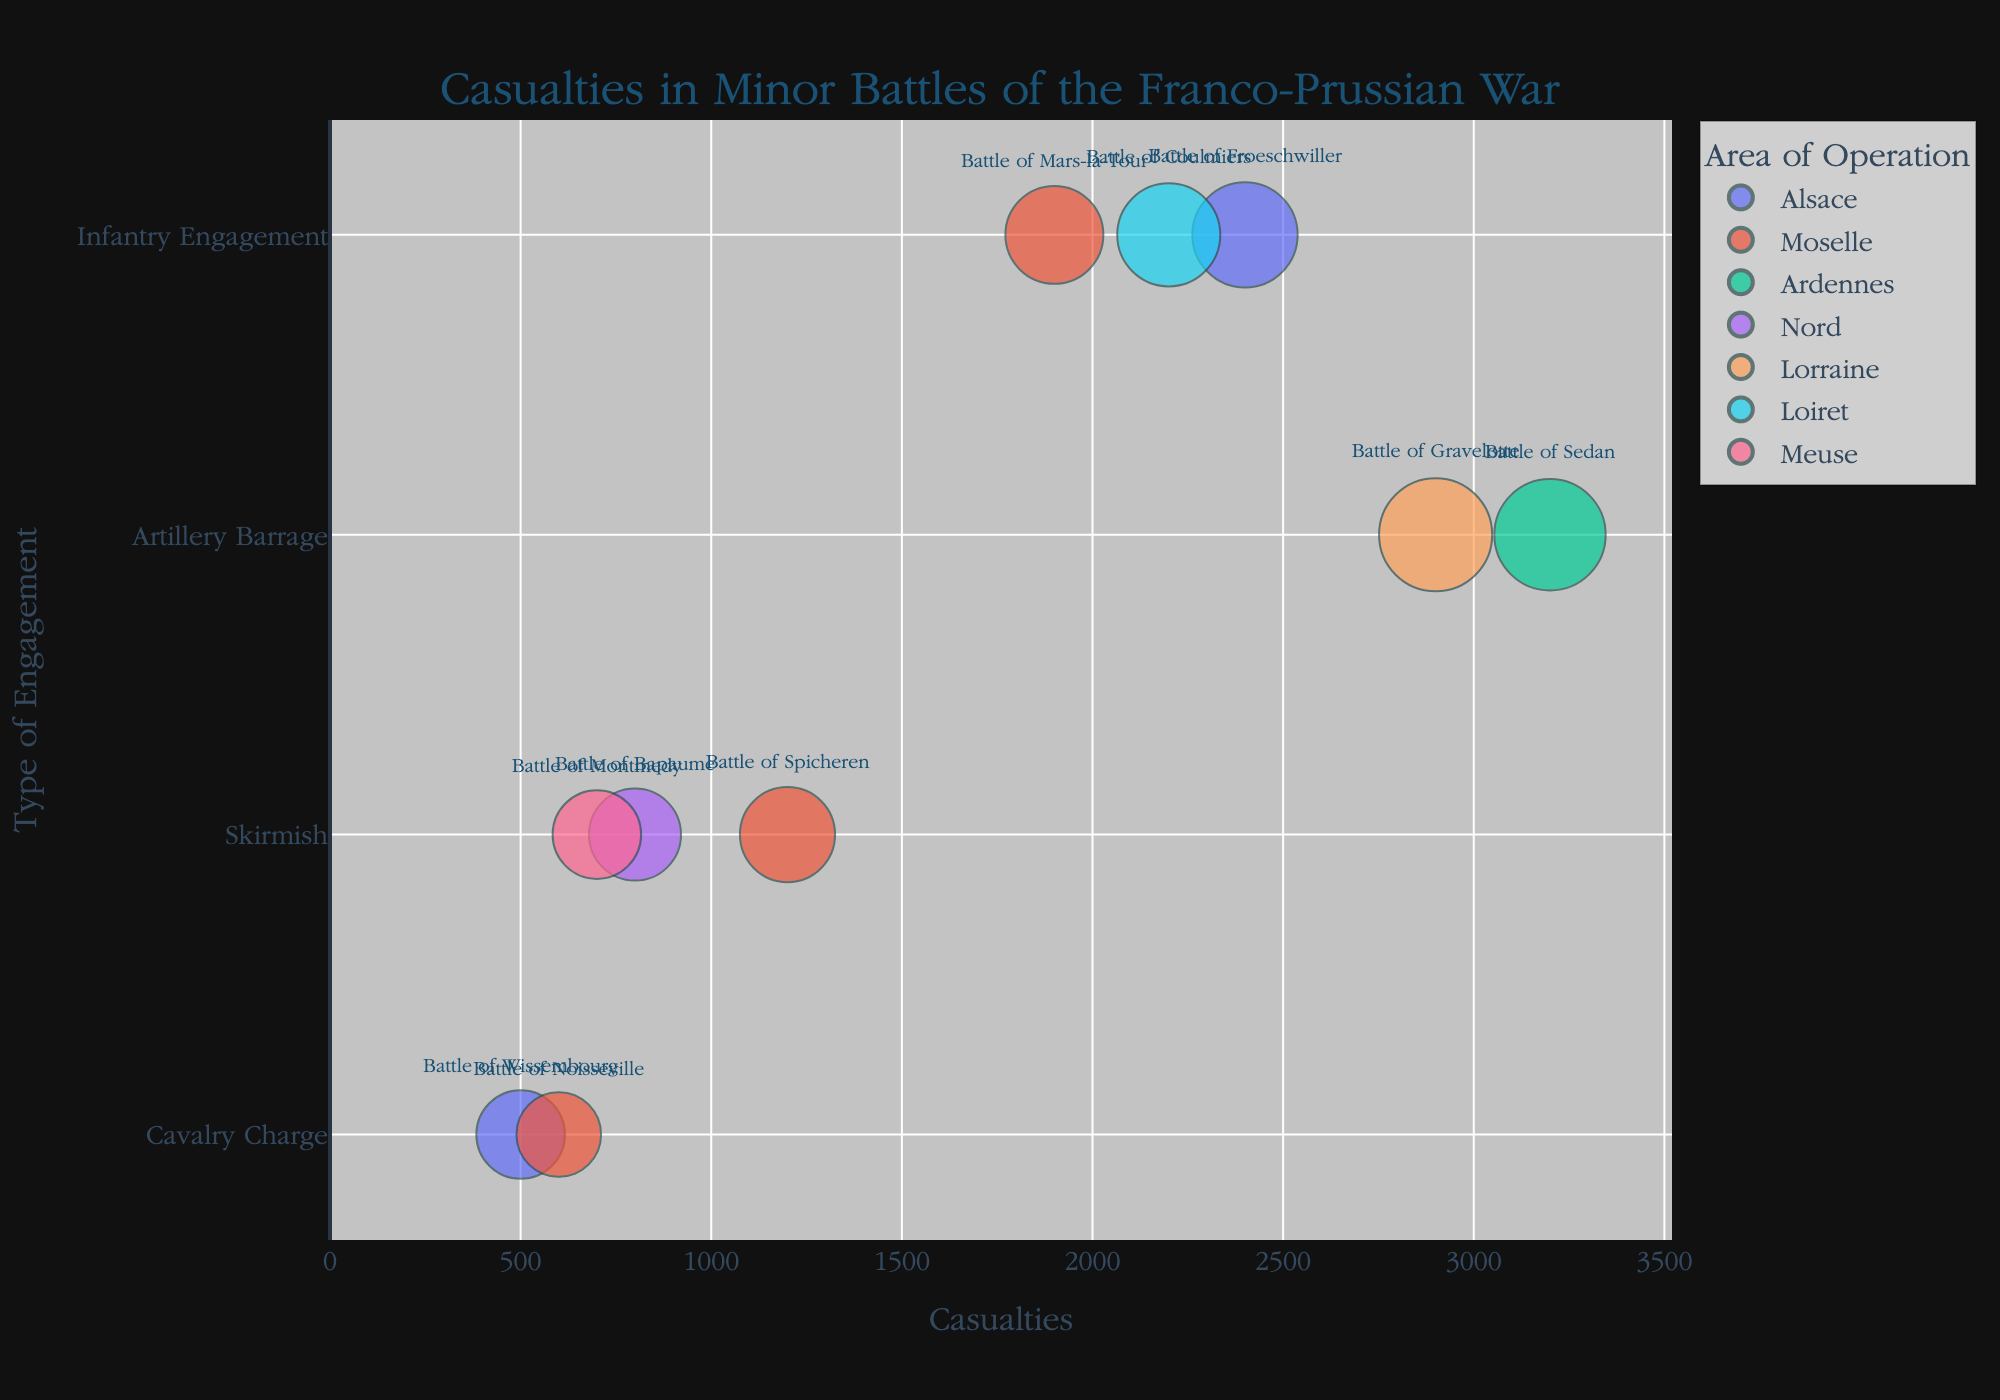Which battle resulted in the highest number of casualties? By examining the x-axis, look for the bubble positioned furthest to the right. This represents the highest number of casualties. The Battle of Sedan has a casualty count of 3,200, making it the highest.
Answer: Battle of Sedan What is the average casualty rate among skirmishes? Identify the bubbles under the "Skirmish" category on the y-axis and sum their casualties: Battle of Spicheren (1,200), Battle of Bapaume (800), and Battle of Montmedy (700). The total is 2,700. There are 3 skirmishes, so the average is 2,700 / 3 = 900.
Answer: 900 Which type of engagement has the smallest and the largest bubbles? Look at the bubble sizes for the different engagement types. The smallest bubble is "Cavalry Charge" (Battle of Wissembourg), and the largest bubble is "Artillery Barrage" (Battle of Gravelotte).
Answer: Cavalry Charge and Artillery Barrage What is the combined casualty rate of all battles taking place in Moselle? Filter the bubbles colored for Moselle: Battle of Spicheren (1,200), Battle of Mars-la-Tour (1,900), Battle of Noisseville (600). Sum these values to get the combined casualty rate. 1,200 + 1,900 + 600 = 3,700.
Answer: 3,700 Which area of operation saw the most battles? Observe the colors of the bubbles to count the occurrences of each area. Moselle has 3 bubbles (Battles of Spicheren, Mars-la-Tour, Noisseville). Alsace, Ardennes, Nord, Lorraine, Loiret, Meuse are only represented 1-2 times.
Answer: Moselle Between battles in Alsace, which battle had fewer casualties, and by how much? Compare the battles in Alsace: Battle of Froeschwiller (2,400 casualties) and Battle of Wissembourg (500 casualties). Subtract to find the difference: 2,400 - 500 = 1,900.
Answer: Battle of Wissembourg by 1,900 How many battles involved more than 10,000 forces? Look at the bubble sizes and/or hover over them to see the number of forces. Identify which battles involved more than 10,000 forces: Battle of Froeschwiller (12,000), Battle of Sedan (15,000), Battle of Gravelotte (16,000), Battle of Coulmiers (11,000). Count these battles: 4.
Answer: 4 What is the total number of casualties from Infantry Engagements? Accumulate casualties from Infantry Engagements: Battle of Froeschwiller (2,400), Battle of Mars-la-Tour (1,900), Battle of Coulmiers (2,200). Sum these numbers: 2,400 + 1,900 + 2,200 = 6,500.
Answer: 6,500 Which battle in the Lorraine region had the highest casualties? Isolate the bubbles colored for Lorraine and compare their casualties. Only the Battle of Gravelotte (2,900) occurred in Lorraine.
Answer: Battle of Gravelotte Does any battle in the category 'Cavalry Charge' have more than 1,000 casualties? Review the battles categorized as 'Cavalry Charge' and check if they exceed 1,000 casualties. Both the Battle of Wissembourg (500) and Battle of Noisseville (600) are below 1,000.
Answer: No 